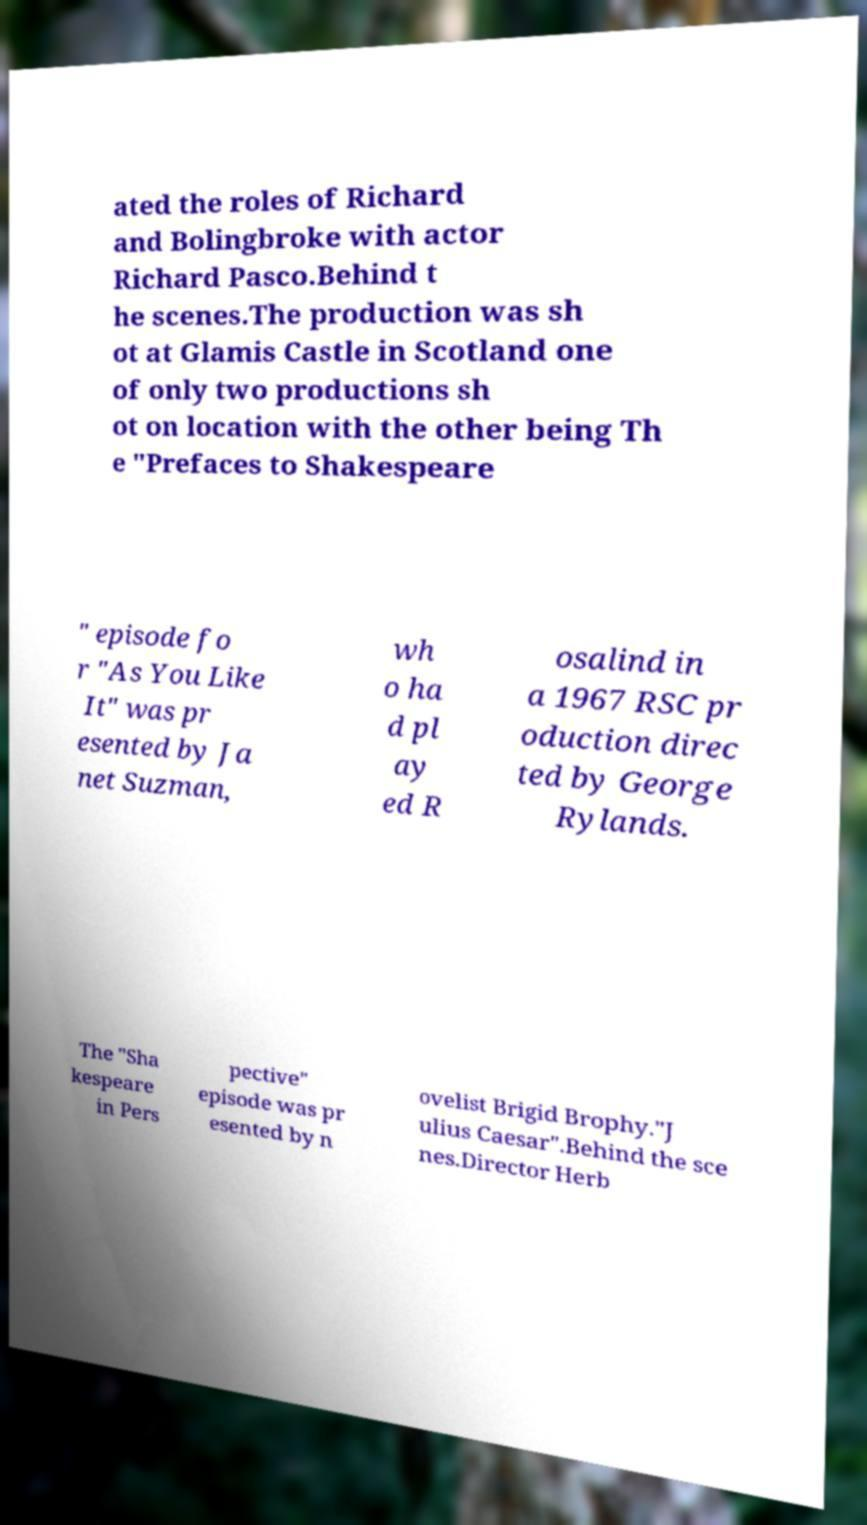Can you accurately transcribe the text from the provided image for me? ated the roles of Richard and Bolingbroke with actor Richard Pasco.Behind t he scenes.The production was sh ot at Glamis Castle in Scotland one of only two productions sh ot on location with the other being Th e "Prefaces to Shakespeare " episode fo r "As You Like It" was pr esented by Ja net Suzman, wh o ha d pl ay ed R osalind in a 1967 RSC pr oduction direc ted by George Rylands. The "Sha kespeare in Pers pective" episode was pr esented by n ovelist Brigid Brophy."J ulius Caesar".Behind the sce nes.Director Herb 